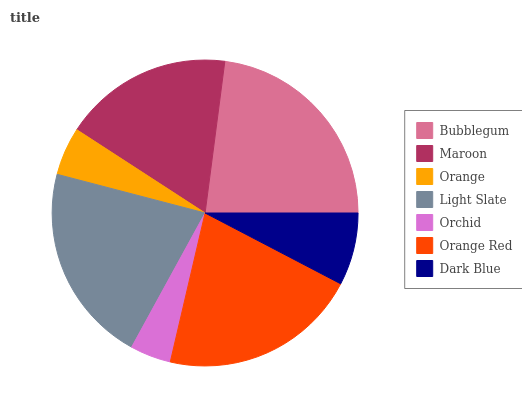Is Orchid the minimum?
Answer yes or no. Yes. Is Bubblegum the maximum?
Answer yes or no. Yes. Is Maroon the minimum?
Answer yes or no. No. Is Maroon the maximum?
Answer yes or no. No. Is Bubblegum greater than Maroon?
Answer yes or no. Yes. Is Maroon less than Bubblegum?
Answer yes or no. Yes. Is Maroon greater than Bubblegum?
Answer yes or no. No. Is Bubblegum less than Maroon?
Answer yes or no. No. Is Maroon the high median?
Answer yes or no. Yes. Is Maroon the low median?
Answer yes or no. Yes. Is Orange Red the high median?
Answer yes or no. No. Is Light Slate the low median?
Answer yes or no. No. 